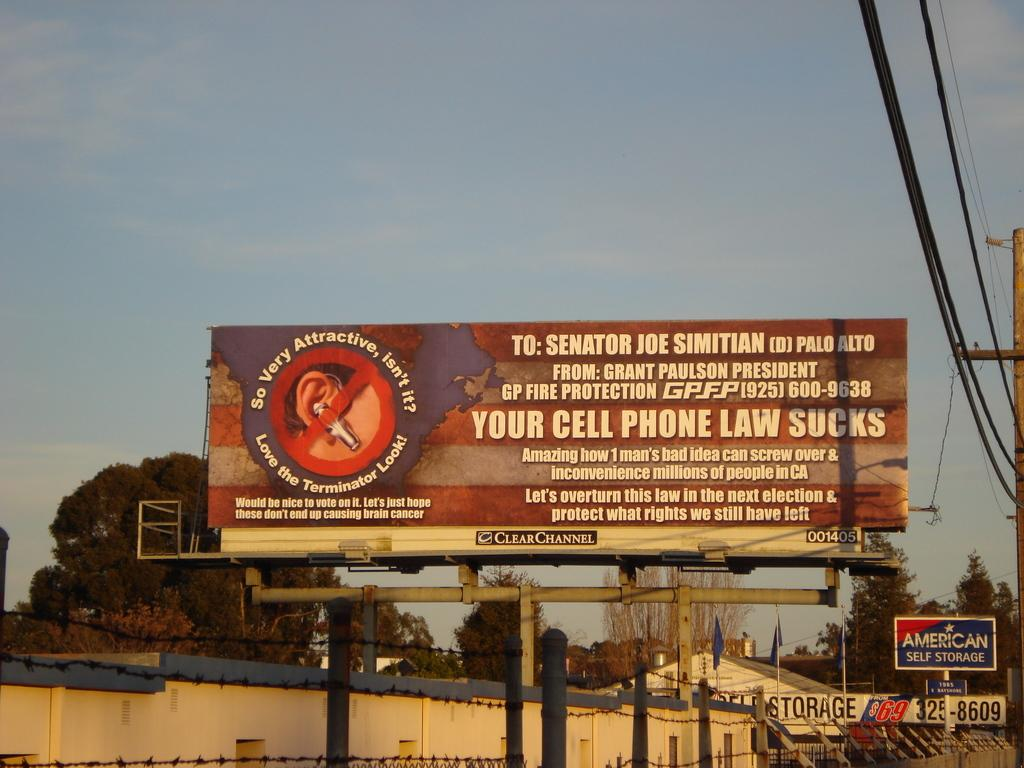<image>
Summarize the visual content of the image. a billboard that says 'your cell phone law sucks' on it 